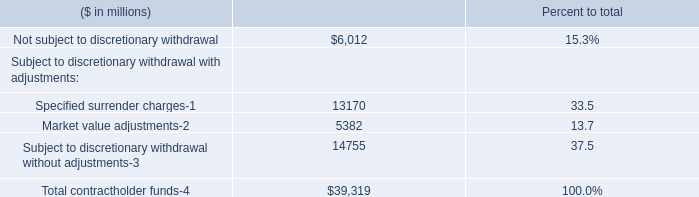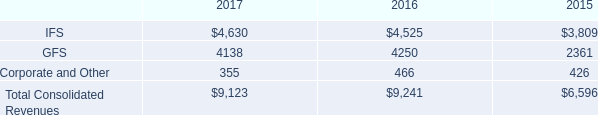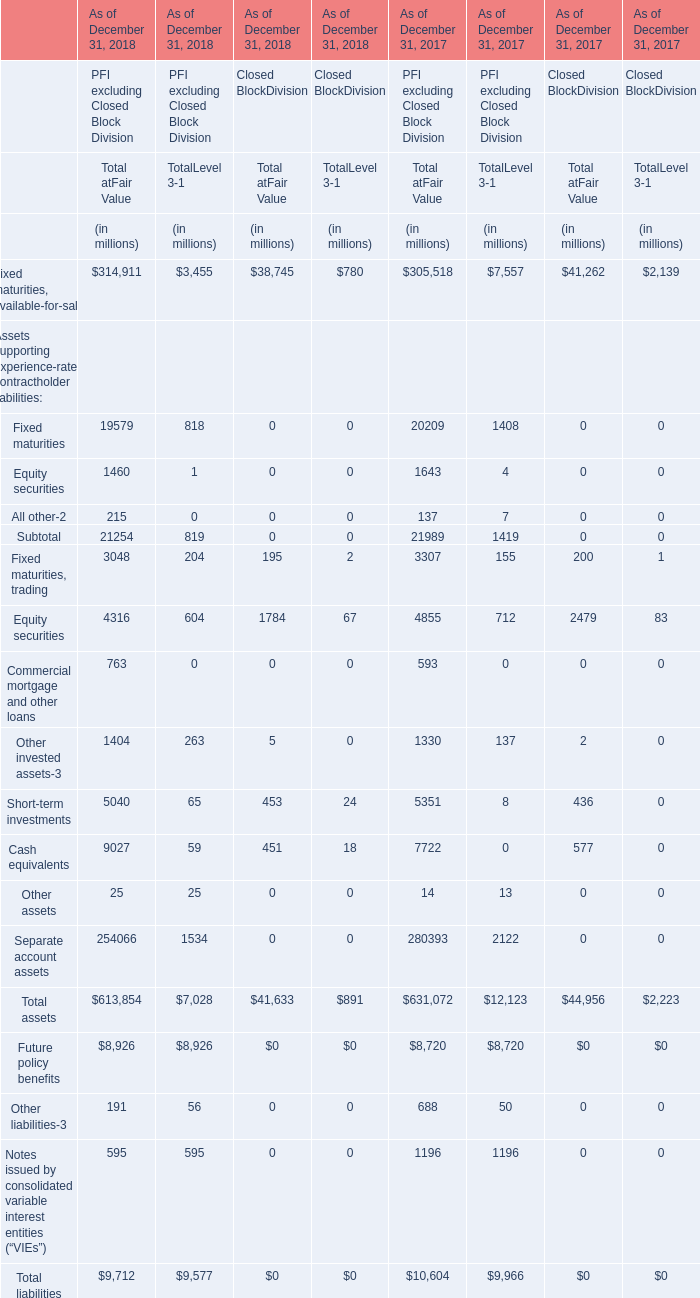What's the growth rate of the value of the Total at Fair Value in terms of Closed Block Division for Total assets on December 31 in 2018? 
Computations: ((41633 - 44956) / 44956)
Answer: -0.07392. 